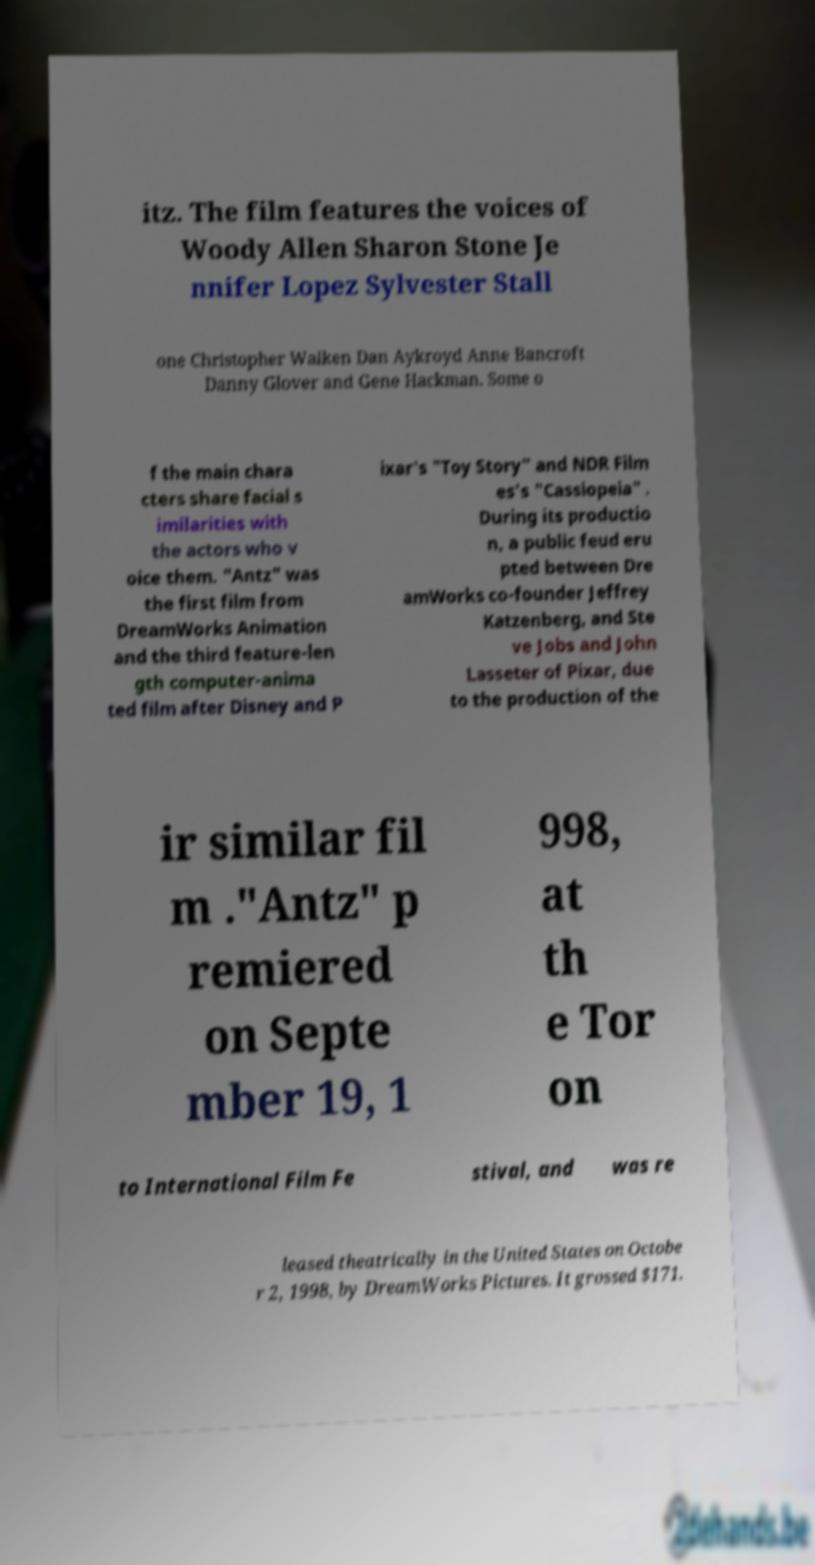Can you read and provide the text displayed in the image?This photo seems to have some interesting text. Can you extract and type it out for me? itz. The film features the voices of Woody Allen Sharon Stone Je nnifer Lopez Sylvester Stall one Christopher Walken Dan Aykroyd Anne Bancroft Danny Glover and Gene Hackman. Some o f the main chara cters share facial s imilarities with the actors who v oice them. "Antz" was the first film from DreamWorks Animation and the third feature-len gth computer-anima ted film after Disney and P ixar's "Toy Story" and NDR Film es's "Cassiopeia" . During its productio n, a public feud eru pted between Dre amWorks co-founder Jeffrey Katzenberg, and Ste ve Jobs and John Lasseter of Pixar, due to the production of the ir similar fil m ."Antz" p remiered on Septe mber 19, 1 998, at th e Tor on to International Film Fe stival, and was re leased theatrically in the United States on Octobe r 2, 1998, by DreamWorks Pictures. It grossed $171. 